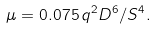Convert formula to latex. <formula><loc_0><loc_0><loc_500><loc_500>\mu = 0 . 0 7 5 \, q ^ { 2 } D ^ { 6 } / S ^ { 4 } .</formula> 